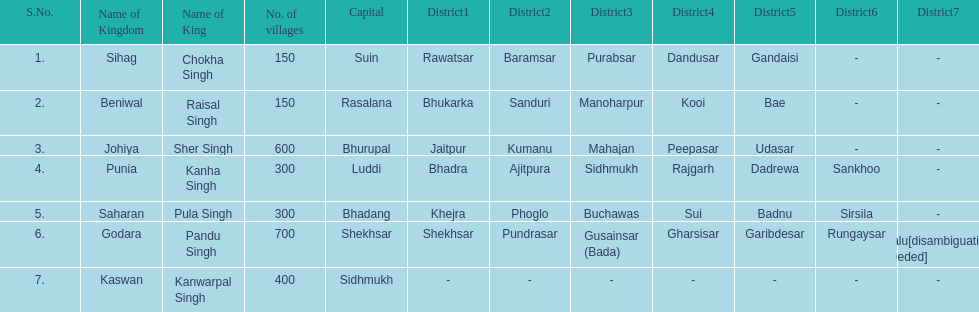Which kingdom has the most villages? Godara. 